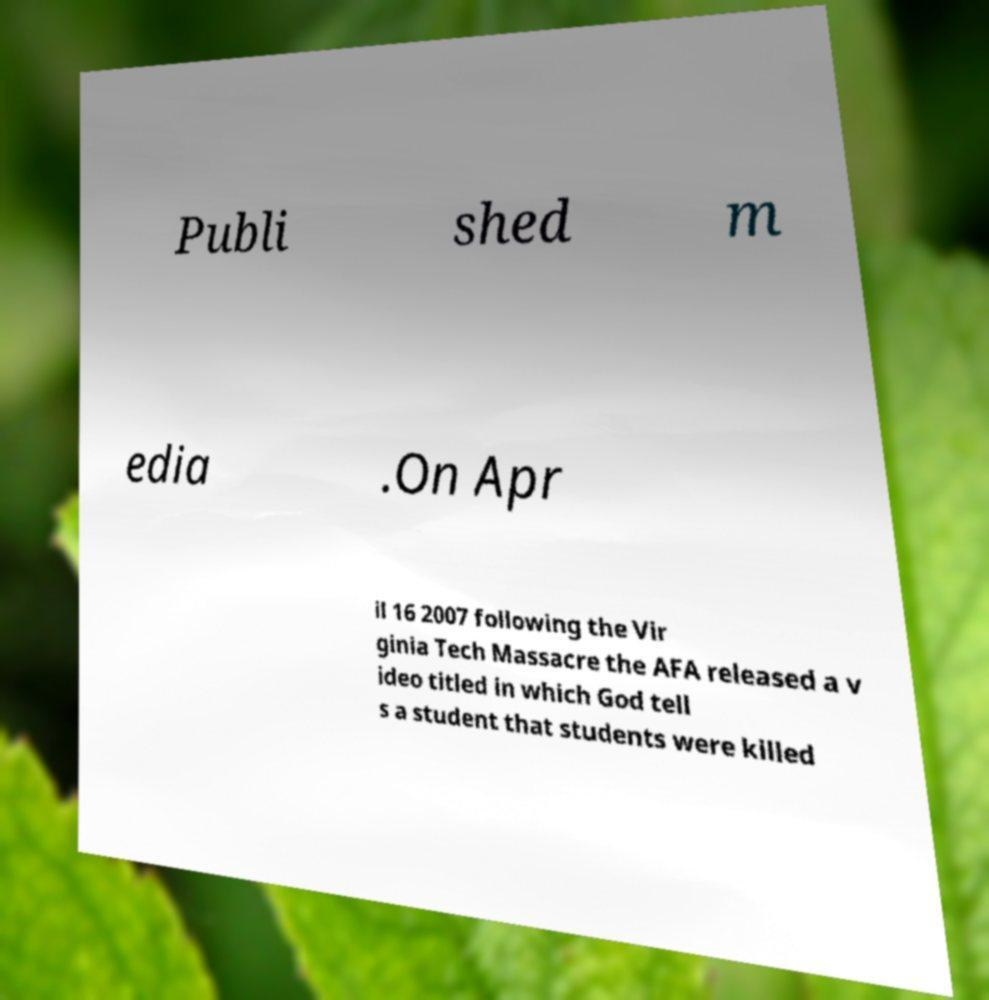What messages or text are displayed in this image? I need them in a readable, typed format. Publi shed m edia .On Apr il 16 2007 following the Vir ginia Tech Massacre the AFA released a v ideo titled in which God tell s a student that students were killed 